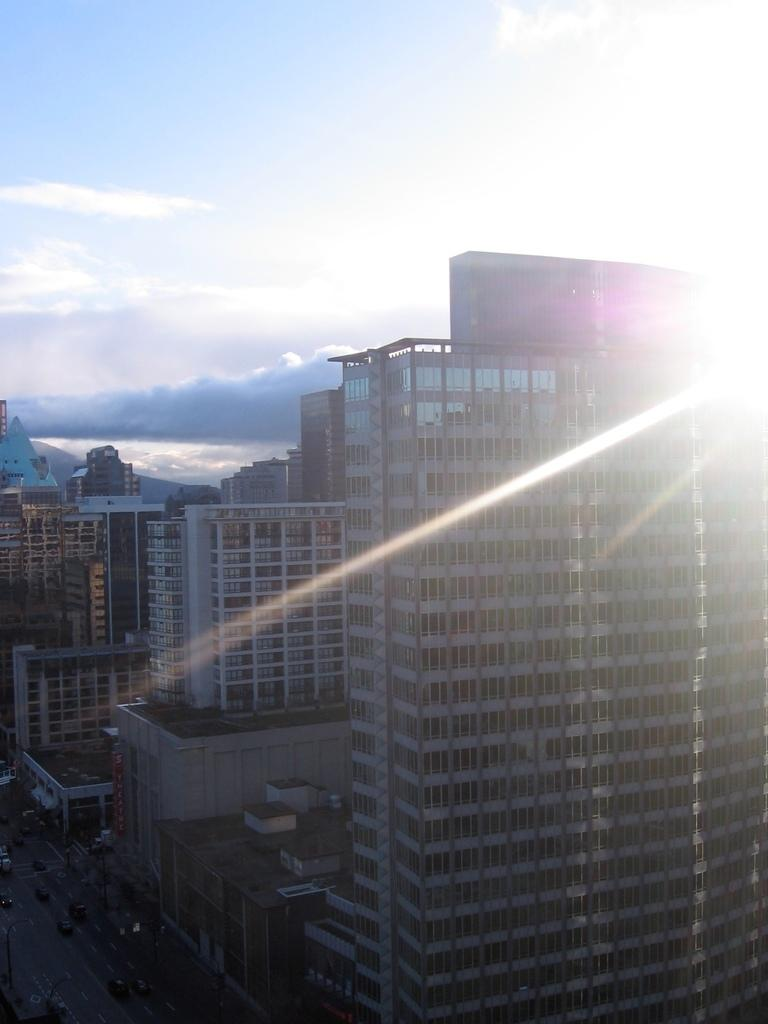What type of structures can be seen in the image? There are buildings in the image. What else can be seen on the ground in the image? There are vehicles on the road in the image. What can be seen in the sky in the image? There are clouds visible in the background of the image. Can you tell me how many pets are visible in the image? There are no pets present in the image. What type of seashore can be seen in the image? There is no seashore present in the image; it features buildings, vehicles, and clouds. 